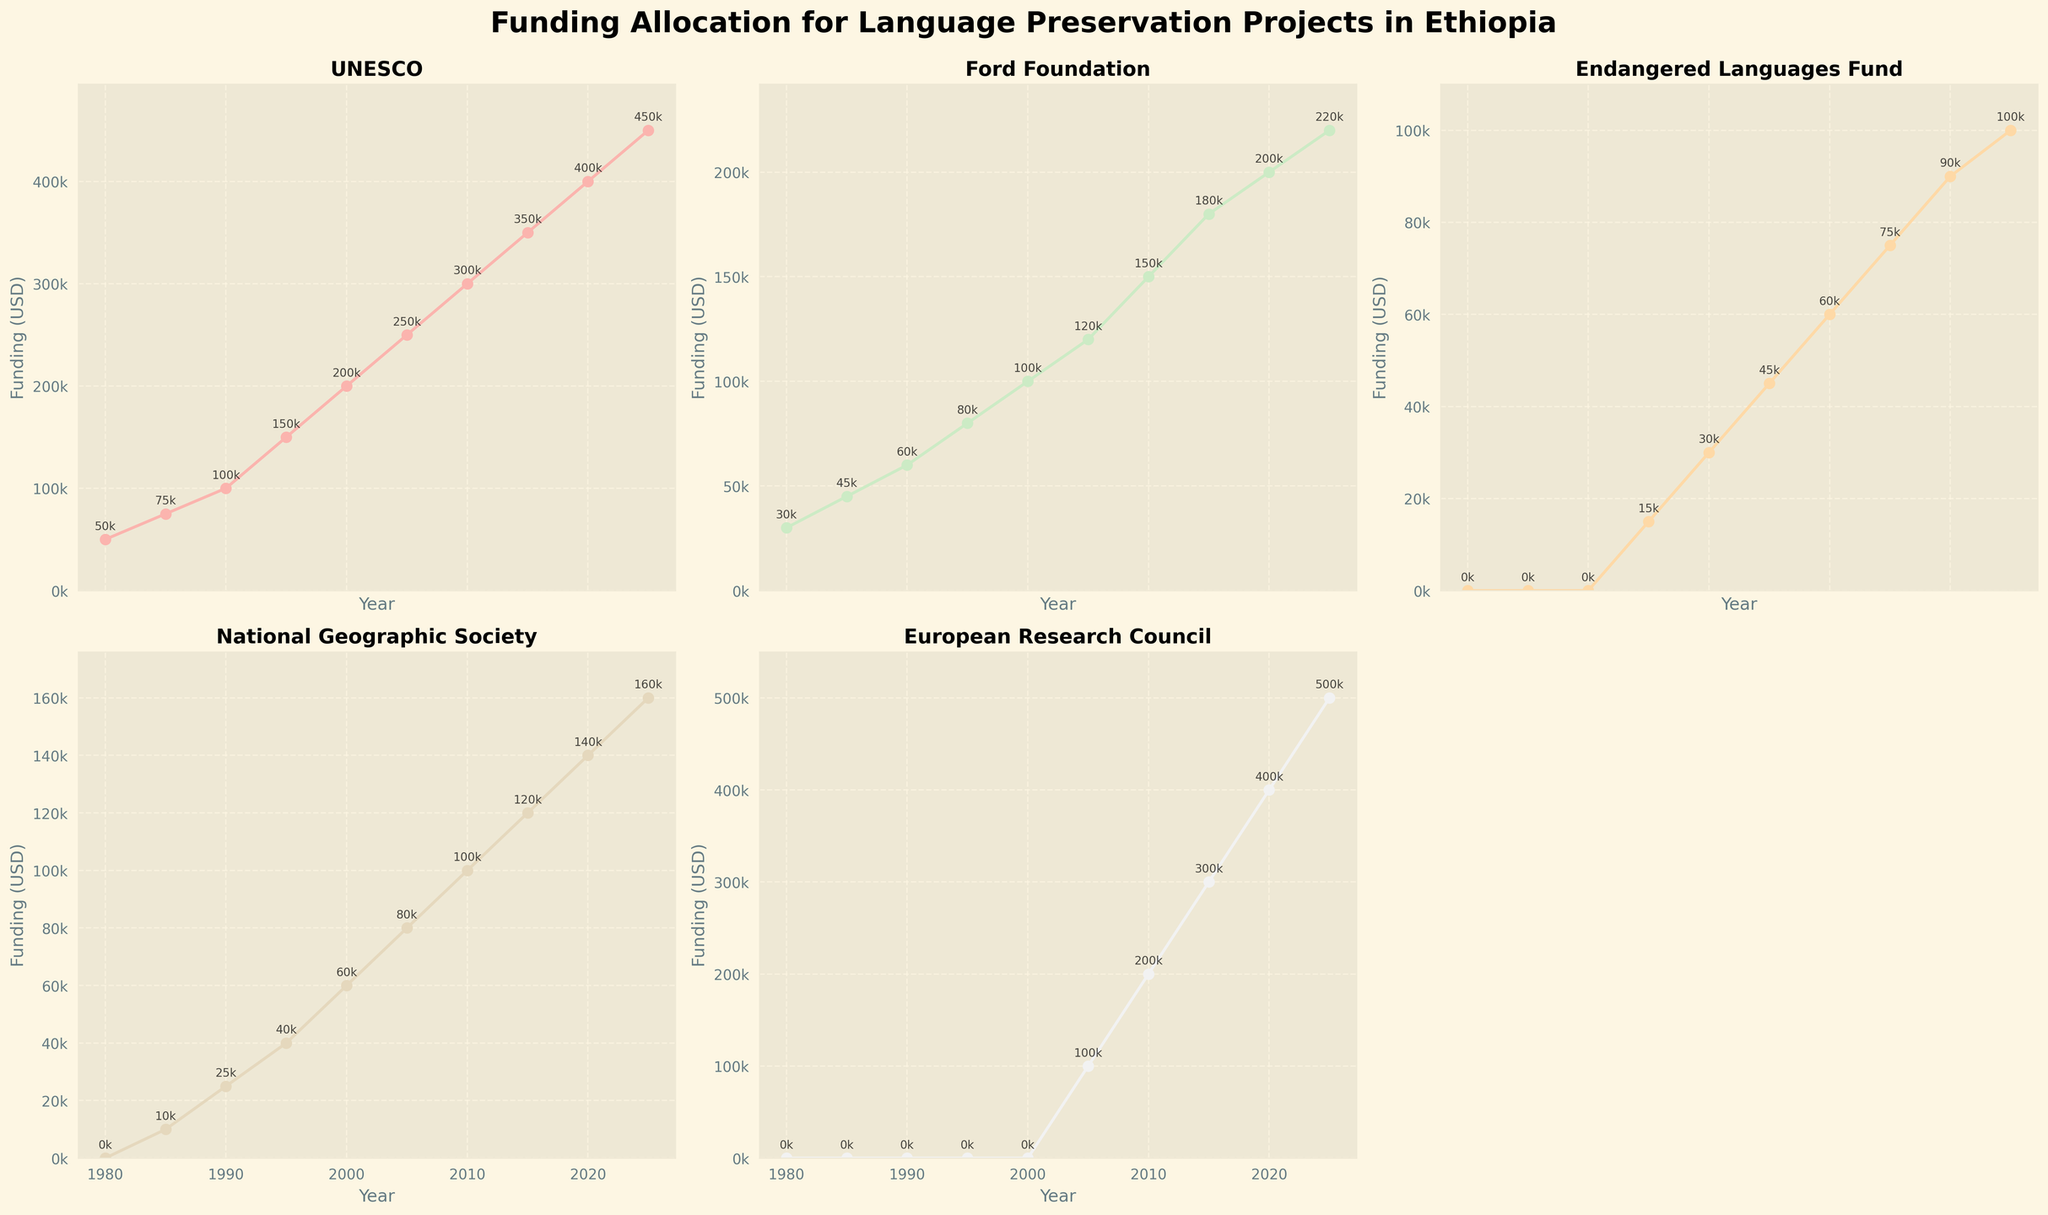What was the total funding from the European Research Council in the years 2020 and 2025? Add the funding amounts for the years 2020 and 2025 from the European Research Council. 400,000 USD (2020) + 500,000 USD (2025) = 900,000 USD
Answer: 900,000 USD Which organization had the highest funding in the year 1995? Compare the funding amounts for all organizations in 1995. UNESCO: 150,000 USD, Ford Foundation: 80,000 USD, Endangered Languages Fund: 15,000 USD, National Geographic Society: 40,000 USD, European Research Council: 0 USD. UNESCO had the highest funding.
Answer: UNESCO Between 2000 and 2010, which organization's funding increased the most? Calculate the increase for each organization from 2000 to 2010: UNESCO: 300,000 - 200,000 = 100,000 USD, Ford Foundation: 150,000 - 100,000 = 50,000 USD, Endangered Languages Fund: 60,000 - 30,000 = 30,000 USD, National Geographic Society: 100,000 - 60,000 = 40,000 USD, European Research Council: 200,000 - 0 = 200,000 USD. The European Research Council had the highest increase.
Answer: European Research Council Which organization started funding language preservation projects after 1980 but before 2000? Look for organizations that had no funding in 1980 but began funding before 2000. National Geographic Society had 0 USD in 1980 and started funding in 1985. Endangered Languages Fund had 0 USD until 1995. The European Research Council started funding in 2005.
Answer: National Geographic Society, Endangered Languages Fund In which year did the National Geographic Society start funding language preservation projects? Identify the first year when National Geographic Society had non-zero funding. The first non-zero funding for National Geographic Society is in 1985 (10,000 USD).
Answer: 1985 What was the average yearly funding by UNESCO from 1980 to 2025? Calculate the average funding by summing up the UNESCO funding amounts and dividing by the number of years: (50,000 + 75,000 + 100,000 + 150,000 + 200,000 + 250,000 + 300,000 + 350,000 + 400,000 + 450,000) / 10 = 232,500 USD
Answer: 232,500 USD Which organization consistently increased its funding every year since it started? Look for an organization that has an ascending line trend without drops. UNESCO, Ford Foundation, Endangered Languages Fund, and National Geographic Society all show consistent increases without decreases since starting. European Research Council starts at a later date but increases consistently.
Answer: UNESCO, Ford Foundation, Endangered Languages Fund, National Geographic Society, European Research Council 